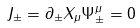<formula> <loc_0><loc_0><loc_500><loc_500>J _ { \pm } = \partial _ { \pm } X _ { \mu } \Psi ^ { \mu } _ { \pm } = 0</formula> 